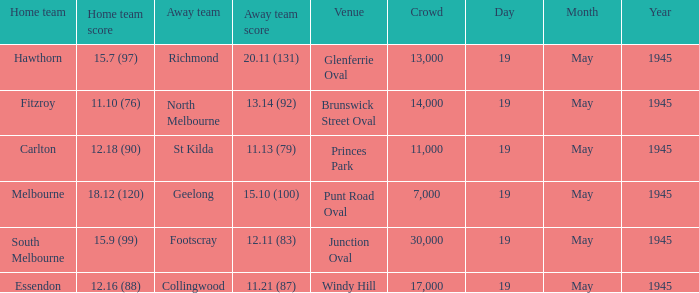On which date was Essendon the home team? 19 May 1945. 